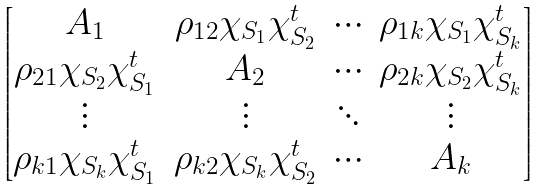Convert formula to latex. <formula><loc_0><loc_0><loc_500><loc_500>\begin{bmatrix} A _ { 1 } & \rho _ { 1 2 } \chi _ { S _ { 1 } } \chi _ { S _ { 2 } } ^ { t } & \cdots & \rho _ { 1 k } \chi _ { S _ { 1 } } \chi _ { S _ { k } } ^ { t } \\ \rho _ { 2 1 } \chi _ { S _ { 2 } } \chi _ { S _ { 1 } } ^ { t } & A _ { 2 } & \cdots & \rho _ { 2 k } \chi _ { S _ { 2 } } \chi _ { S _ { k } } ^ { t } \\ \vdots & \vdots & \ddots & \vdots \\ \rho _ { k 1 } \chi _ { S _ { k } } \chi _ { S _ { 1 } } ^ { t } & \rho _ { k 2 } \chi _ { S _ { k } } \chi _ { S _ { 2 } } ^ { t } & \cdots & A _ { k } \end{bmatrix}</formula> 